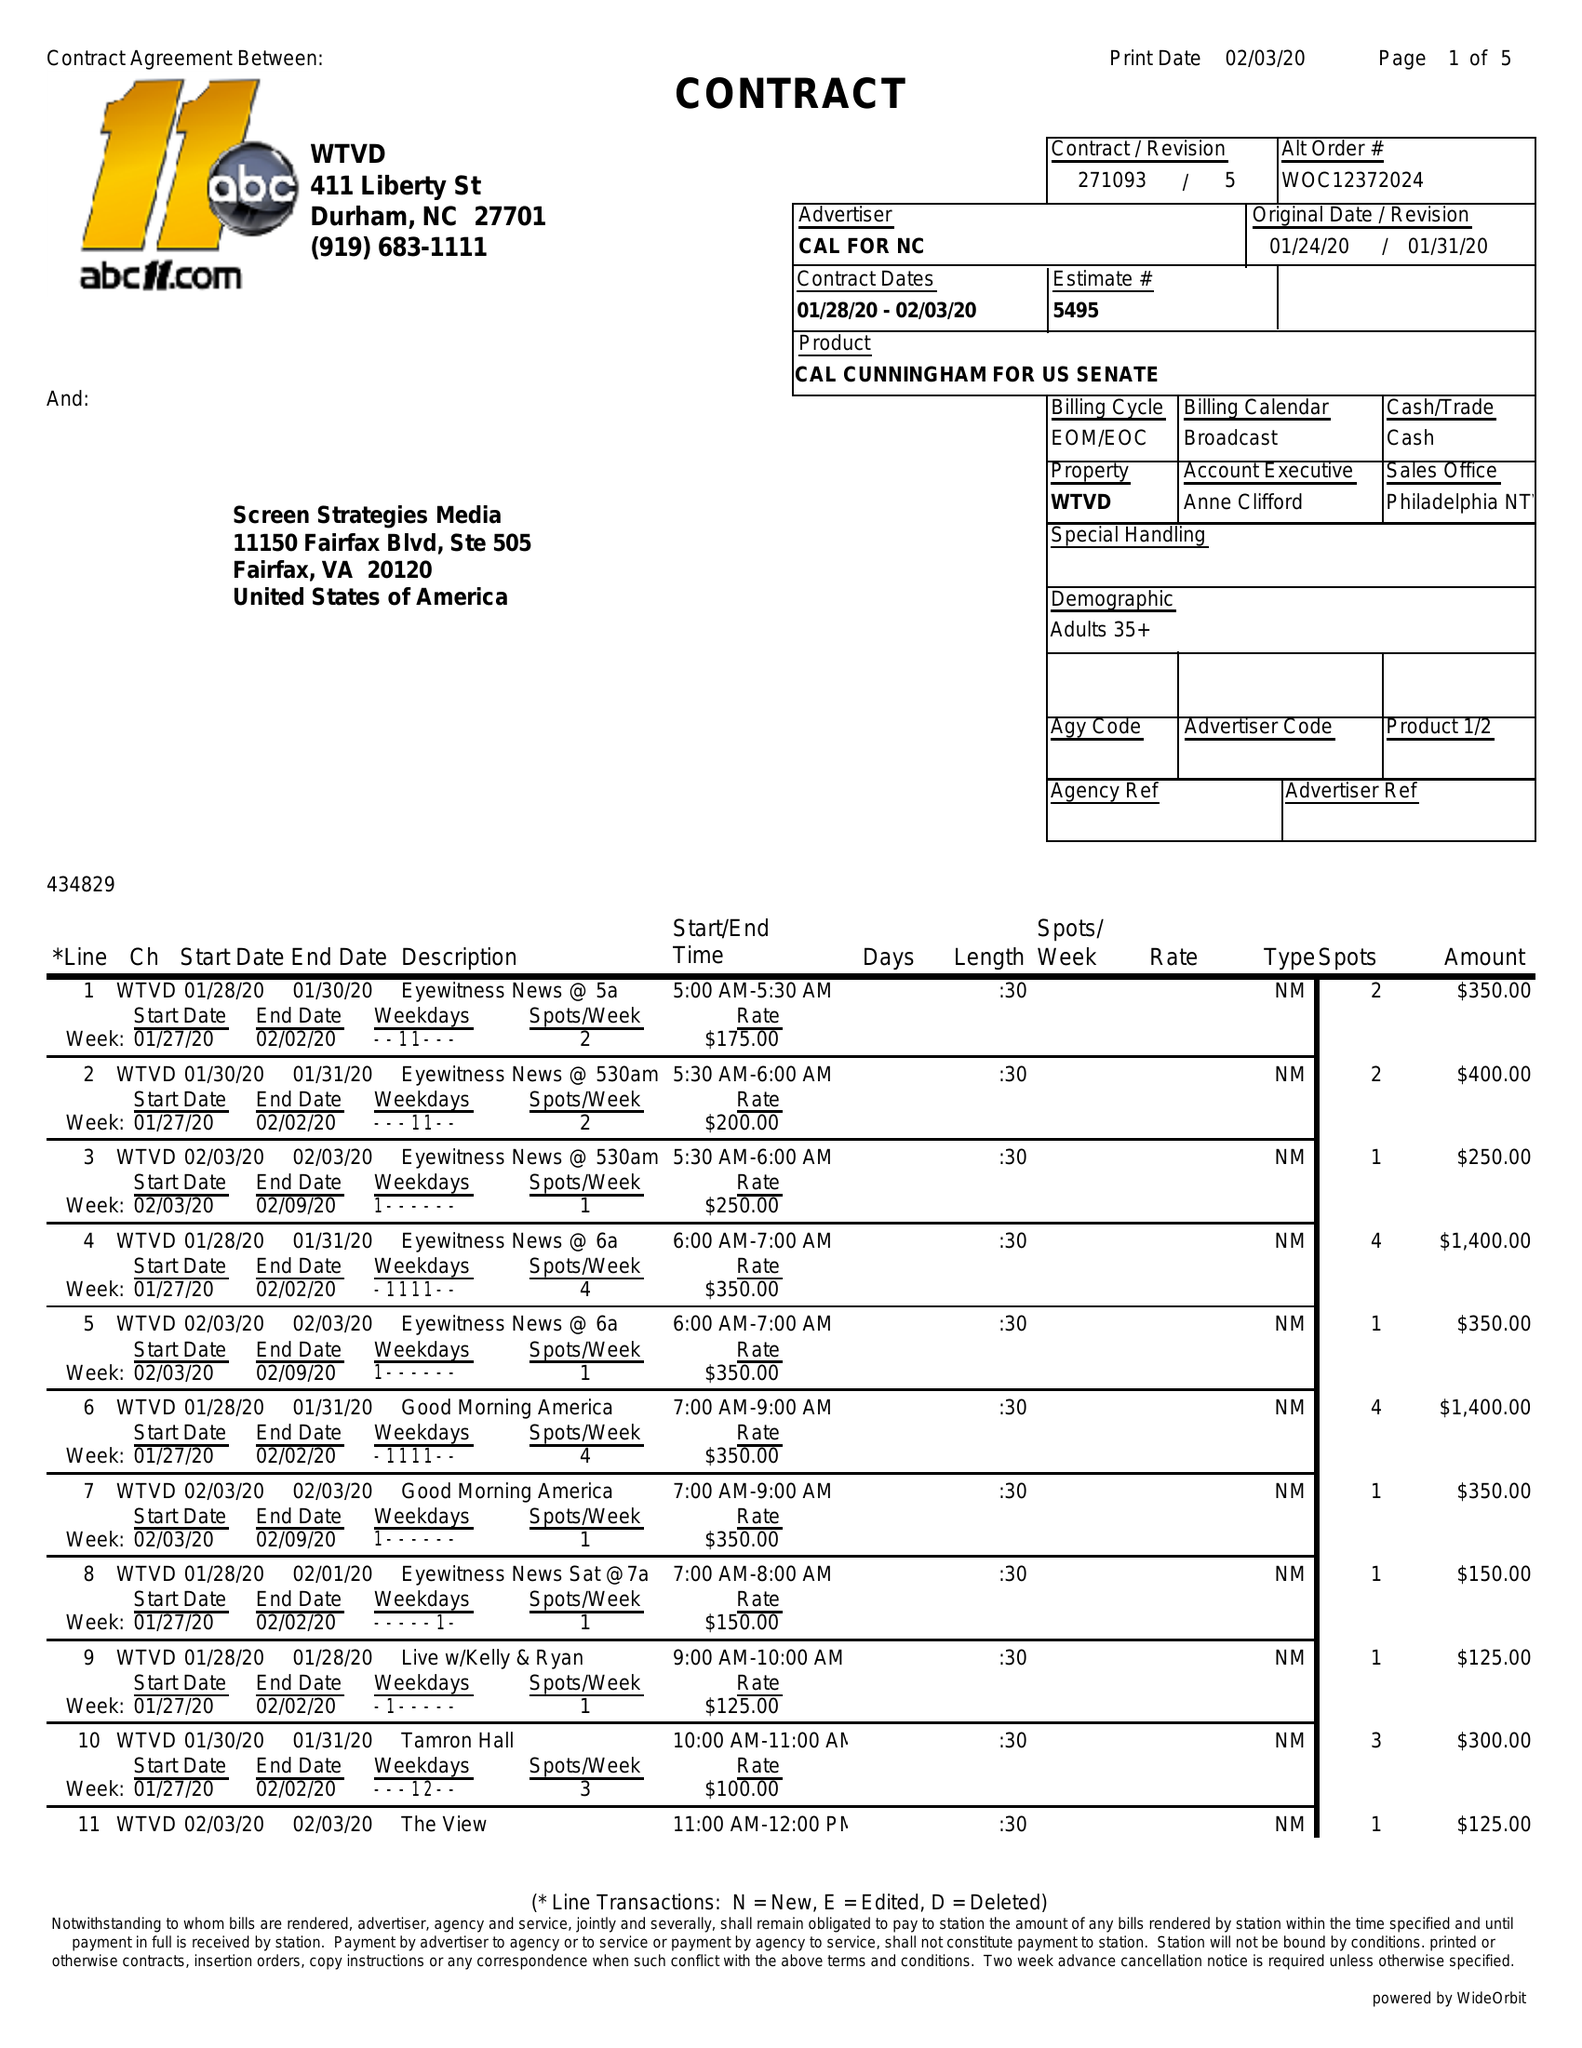What is the value for the gross_amount?
Answer the question using a single word or phrase. 25685.00 